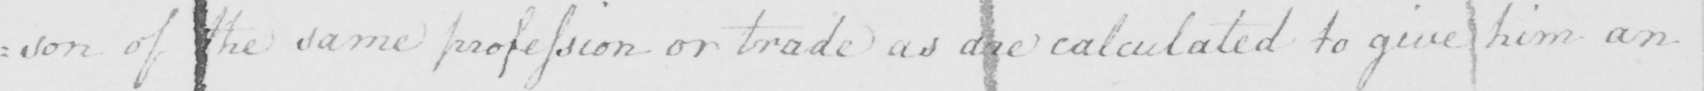Please transcribe the handwritten text in this image. : son of the same profession or trade as are calculated to give him an 